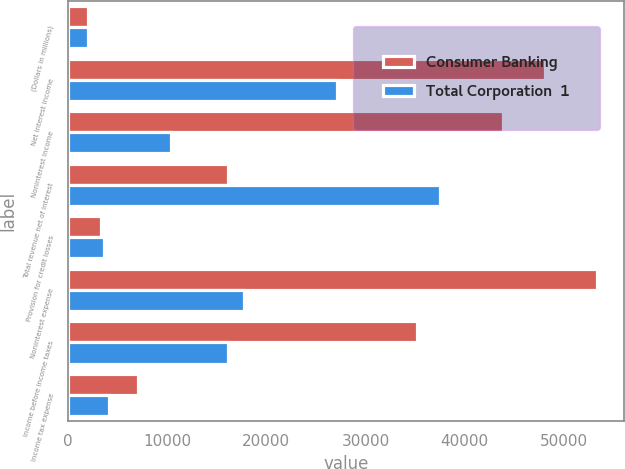Convert chart. <chart><loc_0><loc_0><loc_500><loc_500><stacked_bar_chart><ecel><fcel>(Dollars in millions)<fcel>Net interest income<fcel>Noninterest income<fcel>Total revenue net of interest<fcel>Provision for credit losses<fcel>Noninterest expense<fcel>Income before income taxes<fcel>Income tax expense<nl><fcel>Consumer Banking<fcel>2018<fcel>48042<fcel>43815<fcel>16146<fcel>3282<fcel>53381<fcel>35194<fcel>7047<nl><fcel>Total Corporation  1<fcel>2018<fcel>27123<fcel>10400<fcel>37523<fcel>3664<fcel>17713<fcel>16146<fcel>4117<nl></chart> 